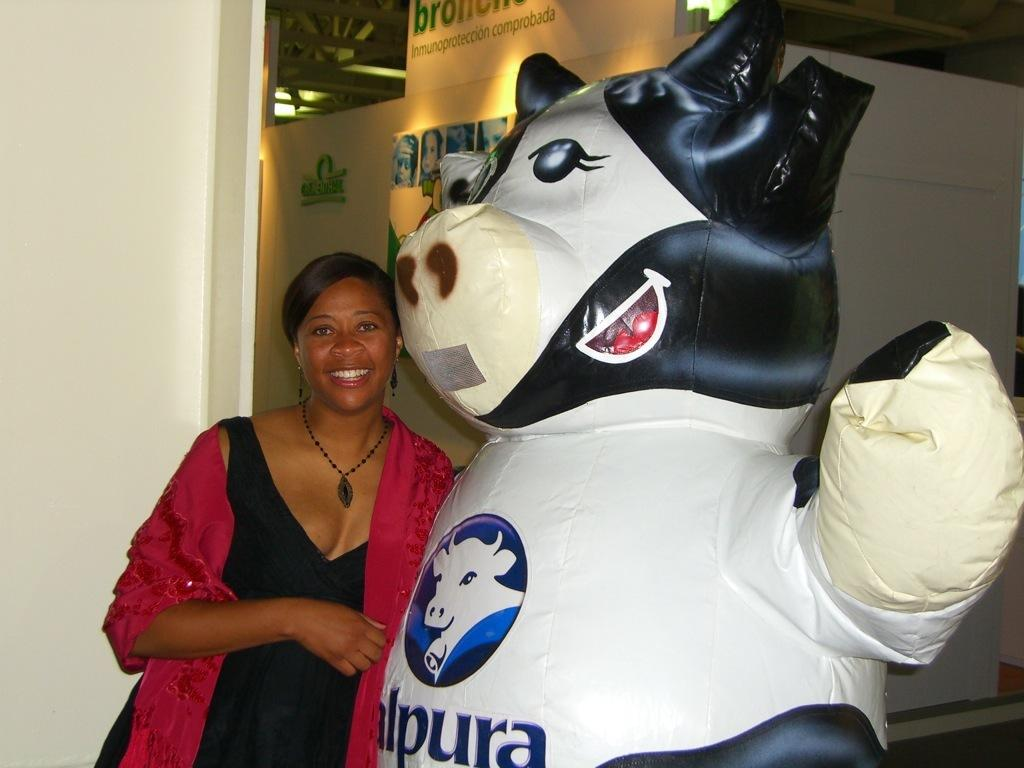<image>
Render a clear and concise summary of the photo. the woman is standing next to a cow figure with letter lpura on it 